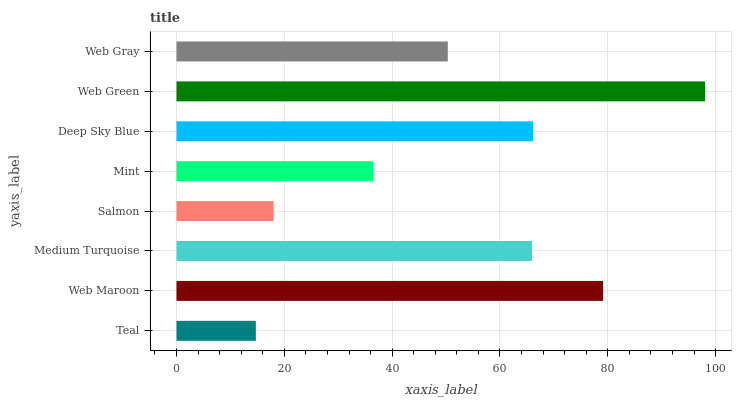Is Teal the minimum?
Answer yes or no. Yes. Is Web Green the maximum?
Answer yes or no. Yes. Is Web Maroon the minimum?
Answer yes or no. No. Is Web Maroon the maximum?
Answer yes or no. No. Is Web Maroon greater than Teal?
Answer yes or no. Yes. Is Teal less than Web Maroon?
Answer yes or no. Yes. Is Teal greater than Web Maroon?
Answer yes or no. No. Is Web Maroon less than Teal?
Answer yes or no. No. Is Medium Turquoise the high median?
Answer yes or no. Yes. Is Web Gray the low median?
Answer yes or no. Yes. Is Mint the high median?
Answer yes or no. No. Is Mint the low median?
Answer yes or no. No. 